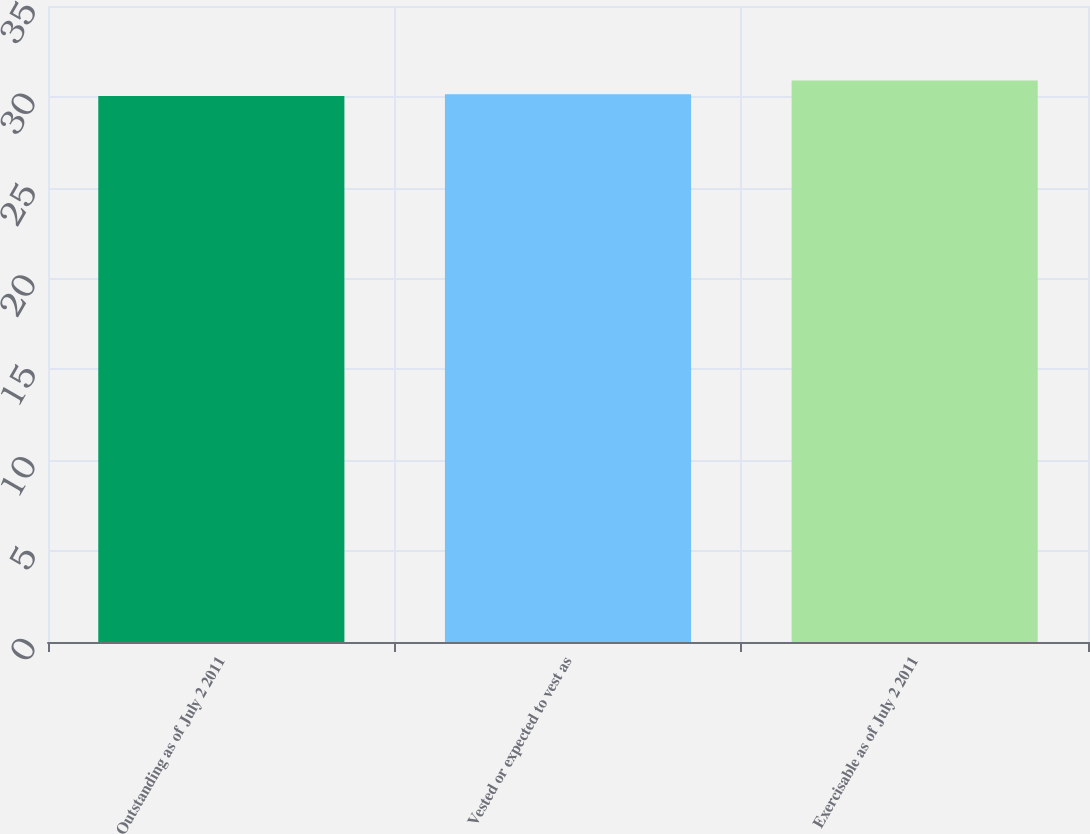Convert chart to OTSL. <chart><loc_0><loc_0><loc_500><loc_500><bar_chart><fcel>Outstanding as of July 2 2011<fcel>Vested or expected to vest as<fcel>Exercisable as of July 2 2011<nl><fcel>30.05<fcel>30.14<fcel>30.9<nl></chart> 